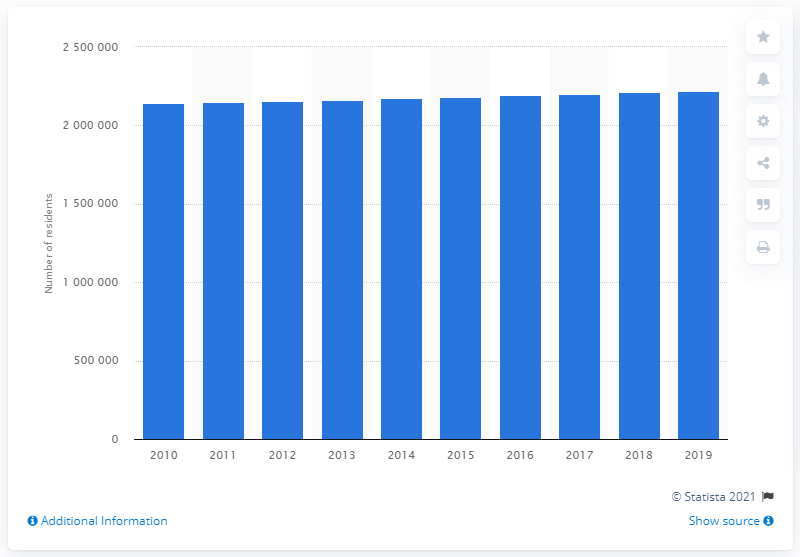Give some essential details in this illustration. In 2019, an estimated 2,202,558 individuals lived within the Cincinnati metropolitan area. 